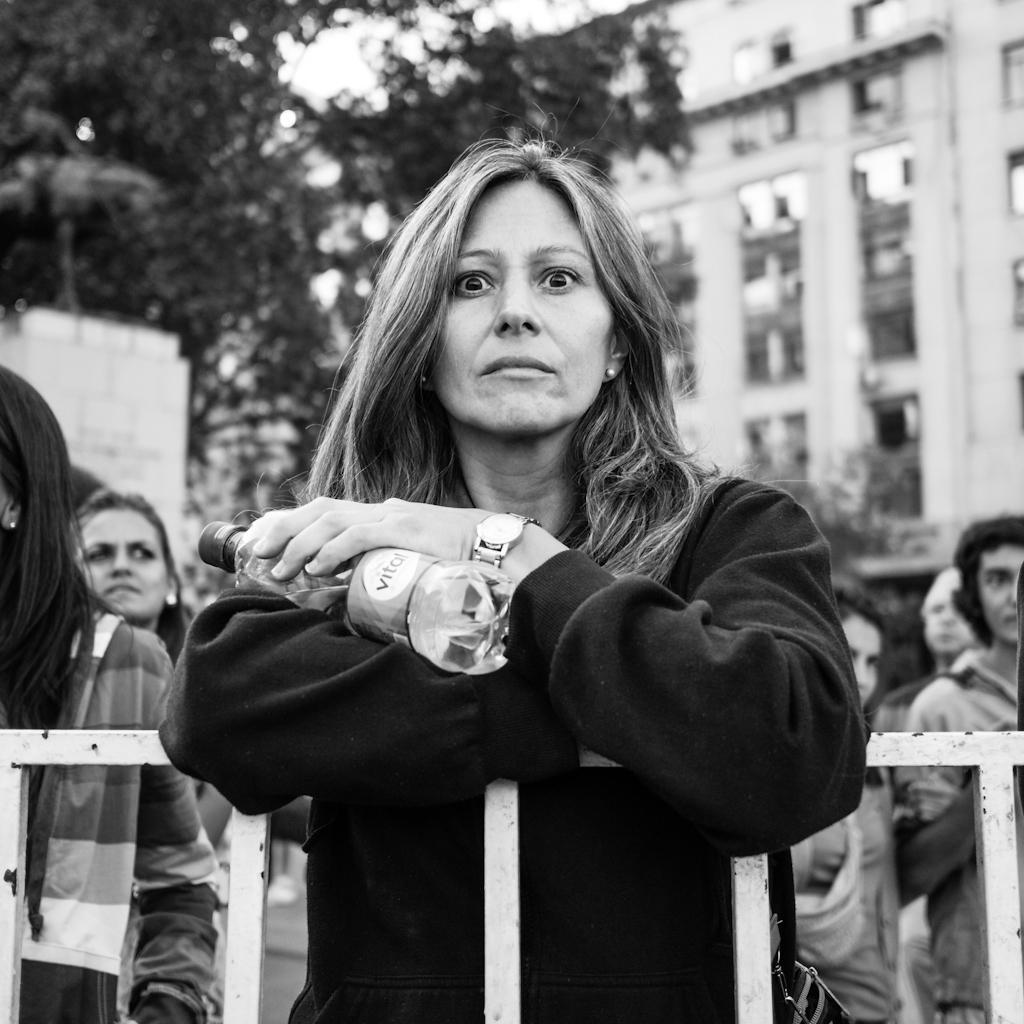Describe this image in one or two sentences. This is a black and white image. In this image we can see a woman standing beside a fence holding a bottle. On the backside we can see a group of people standing, a building with windows, a tree and the sky. 